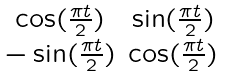<formula> <loc_0><loc_0><loc_500><loc_500>\begin{smallmatrix} \cos ( \frac { \pi t } { 2 } ) & \sin ( \frac { \pi t } { 2 } ) \\ - \sin ( \frac { \pi t } { 2 } ) & \cos ( \frac { \pi t } { 2 } ) \end{smallmatrix}</formula> 